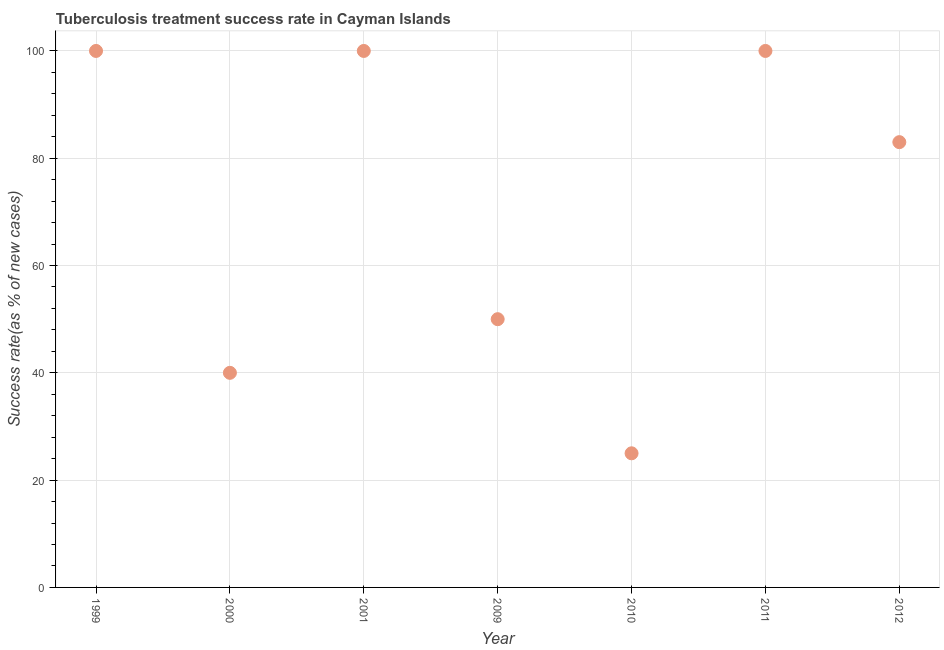What is the tuberculosis treatment success rate in 2001?
Your answer should be compact. 100. Across all years, what is the maximum tuberculosis treatment success rate?
Your answer should be compact. 100. Across all years, what is the minimum tuberculosis treatment success rate?
Your answer should be very brief. 25. In which year was the tuberculosis treatment success rate maximum?
Your answer should be compact. 1999. What is the sum of the tuberculosis treatment success rate?
Give a very brief answer. 498. What is the difference between the tuberculosis treatment success rate in 2009 and 2011?
Offer a terse response. -50. What is the average tuberculosis treatment success rate per year?
Offer a very short reply. 71.14. Do a majority of the years between 1999 and 2010 (inclusive) have tuberculosis treatment success rate greater than 4 %?
Make the answer very short. Yes. Is the tuberculosis treatment success rate in 2010 less than that in 2011?
Provide a short and direct response. Yes. What is the difference between the highest and the second highest tuberculosis treatment success rate?
Offer a very short reply. 0. What is the difference between the highest and the lowest tuberculosis treatment success rate?
Ensure brevity in your answer.  75. Does the tuberculosis treatment success rate monotonically increase over the years?
Your answer should be very brief. No. How many years are there in the graph?
Provide a succinct answer. 7. Does the graph contain any zero values?
Your answer should be very brief. No. What is the title of the graph?
Your answer should be very brief. Tuberculosis treatment success rate in Cayman Islands. What is the label or title of the Y-axis?
Provide a short and direct response. Success rate(as % of new cases). What is the Success rate(as % of new cases) in 2010?
Make the answer very short. 25. What is the Success rate(as % of new cases) in 2012?
Ensure brevity in your answer.  83. What is the difference between the Success rate(as % of new cases) in 1999 and 2010?
Provide a succinct answer. 75. What is the difference between the Success rate(as % of new cases) in 1999 and 2012?
Provide a short and direct response. 17. What is the difference between the Success rate(as % of new cases) in 2000 and 2001?
Keep it short and to the point. -60. What is the difference between the Success rate(as % of new cases) in 2000 and 2009?
Offer a terse response. -10. What is the difference between the Success rate(as % of new cases) in 2000 and 2010?
Offer a very short reply. 15. What is the difference between the Success rate(as % of new cases) in 2000 and 2011?
Your answer should be compact. -60. What is the difference between the Success rate(as % of new cases) in 2000 and 2012?
Make the answer very short. -43. What is the difference between the Success rate(as % of new cases) in 2001 and 2009?
Make the answer very short. 50. What is the difference between the Success rate(as % of new cases) in 2001 and 2011?
Offer a terse response. 0. What is the difference between the Success rate(as % of new cases) in 2001 and 2012?
Keep it short and to the point. 17. What is the difference between the Success rate(as % of new cases) in 2009 and 2010?
Your answer should be compact. 25. What is the difference between the Success rate(as % of new cases) in 2009 and 2011?
Your answer should be very brief. -50. What is the difference between the Success rate(as % of new cases) in 2009 and 2012?
Offer a terse response. -33. What is the difference between the Success rate(as % of new cases) in 2010 and 2011?
Keep it short and to the point. -75. What is the difference between the Success rate(as % of new cases) in 2010 and 2012?
Make the answer very short. -58. What is the difference between the Success rate(as % of new cases) in 2011 and 2012?
Keep it short and to the point. 17. What is the ratio of the Success rate(as % of new cases) in 1999 to that in 2000?
Offer a very short reply. 2.5. What is the ratio of the Success rate(as % of new cases) in 1999 to that in 2001?
Provide a short and direct response. 1. What is the ratio of the Success rate(as % of new cases) in 1999 to that in 2010?
Ensure brevity in your answer.  4. What is the ratio of the Success rate(as % of new cases) in 1999 to that in 2012?
Ensure brevity in your answer.  1.21. What is the ratio of the Success rate(as % of new cases) in 2000 to that in 2001?
Give a very brief answer. 0.4. What is the ratio of the Success rate(as % of new cases) in 2000 to that in 2011?
Offer a very short reply. 0.4. What is the ratio of the Success rate(as % of new cases) in 2000 to that in 2012?
Ensure brevity in your answer.  0.48. What is the ratio of the Success rate(as % of new cases) in 2001 to that in 2010?
Give a very brief answer. 4. What is the ratio of the Success rate(as % of new cases) in 2001 to that in 2012?
Your answer should be compact. 1.21. What is the ratio of the Success rate(as % of new cases) in 2009 to that in 2012?
Make the answer very short. 0.6. What is the ratio of the Success rate(as % of new cases) in 2010 to that in 2012?
Your answer should be compact. 0.3. What is the ratio of the Success rate(as % of new cases) in 2011 to that in 2012?
Give a very brief answer. 1.21. 